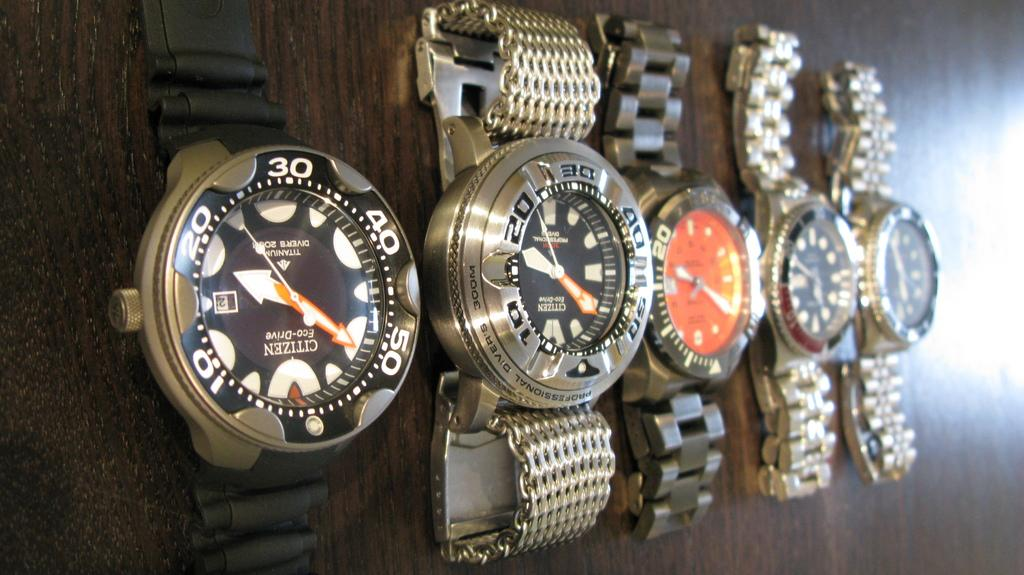Provide a one-sentence caption for the provided image. A line up of 5 watches Citizen can be seen on the first watch to the left. 